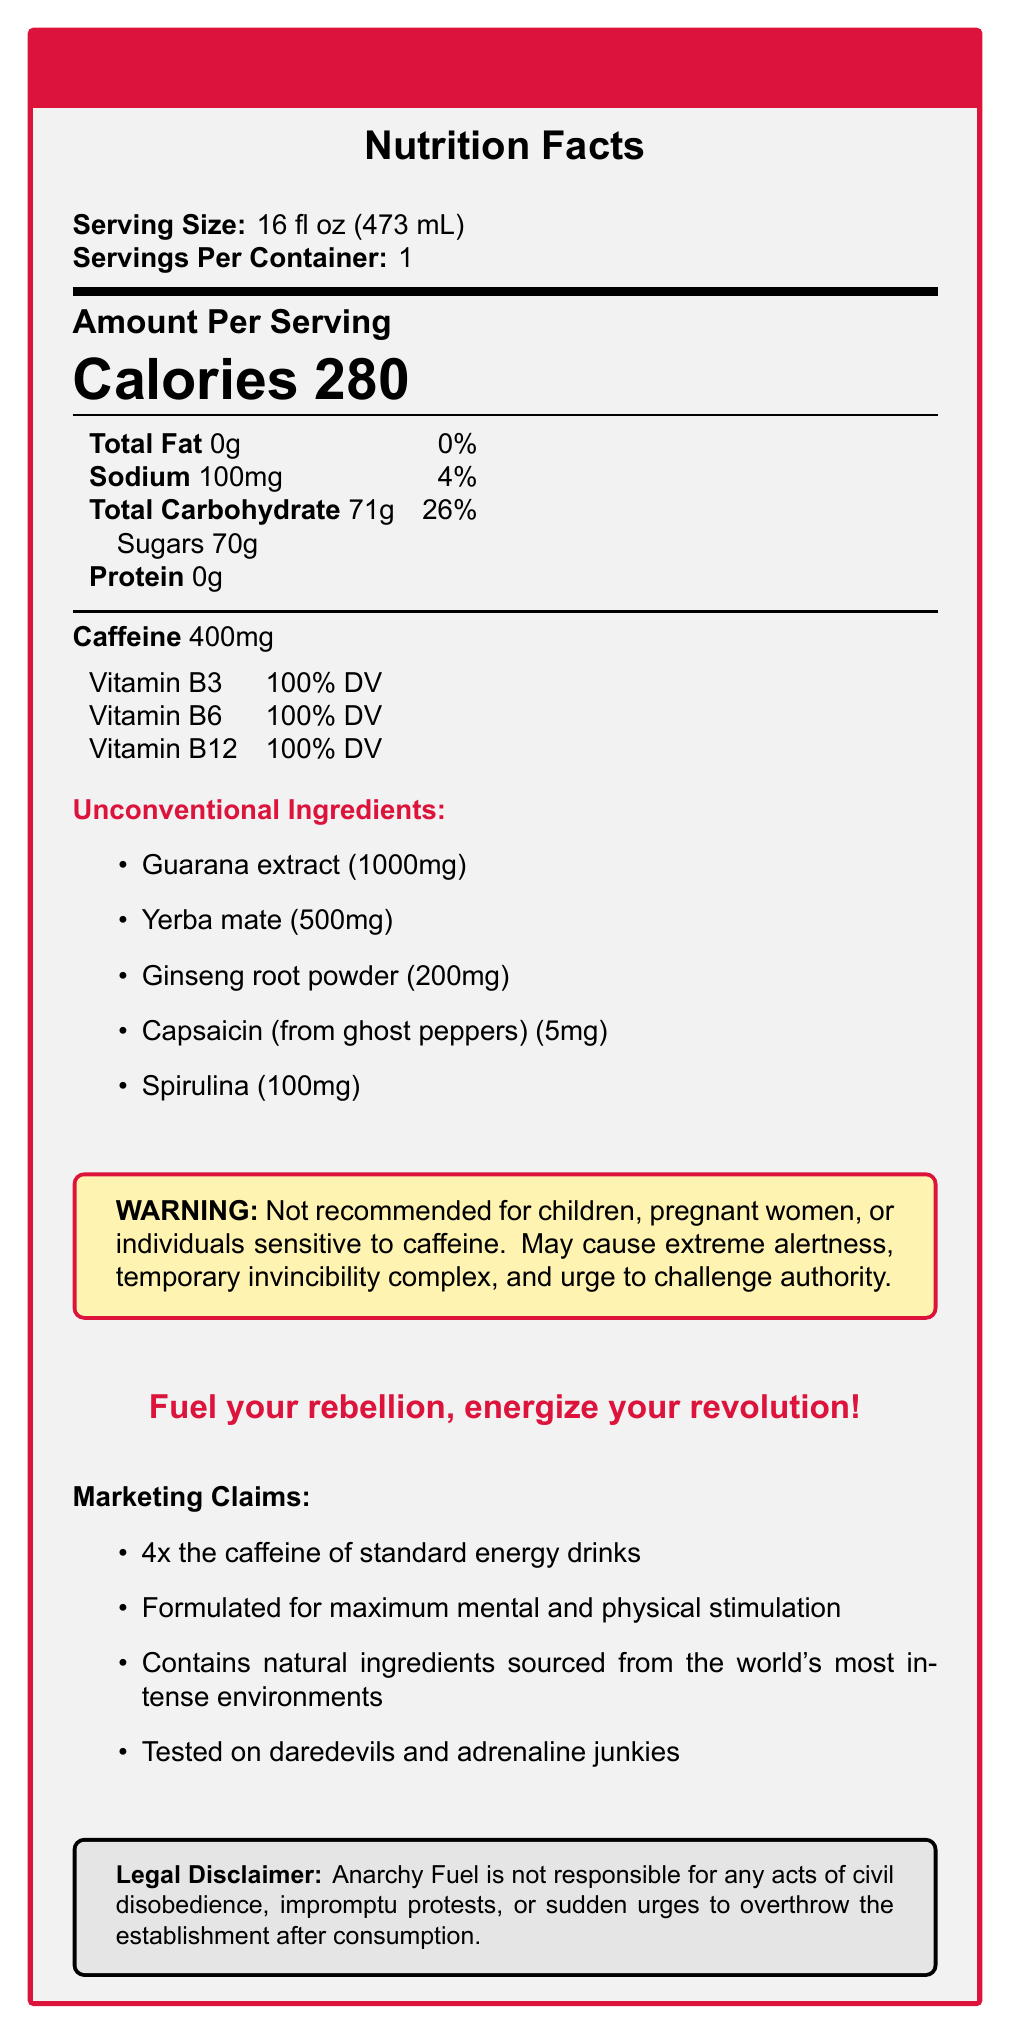what is the serving size of Anarchy Fuel? The serving size is clearly mentioned in the "Serving Size" section of the Nutrition Facts, indicating it is 16 fl oz (473 mL).
Answer: 16 fl oz (473 mL) how many grams of sugars are in one serving of Anarchy Fuel? The sugars content is listed under "Total Carbohydrate" in the Nutrition Facts section.
Answer: 70g how much caffeine does Anarchy Fuel contain? The caffeine content is specifically stated in the document as 400mg per serving.
Answer: 400mg what are the unconventional ingredients in Anarchy Fuel? The list of unconventional ingredients is provided in the "Unconventional Ingredients" section.
Answer: Guarana extract, Yerba mate, Ginseng root powder, Capsaicin (from ghost peppers), Spirulina what percentage of Vitamin B6 is in Anarchy Fuel? The percentage of Vitamin B6 is clearly indicated in the vitamins and minerals section of the Nutrition Facts.
Answer: 100% DV how much sodium is in Anarchy Fuel? The sodium content is listed in the Nutrition Facts.
Answer: 100mg which of the following statements about Anarchy Fuel is true?
A. It contains dairy products.
B. It is low in sugar.
C. It is not recommended for children or pregnant women. Statement A is incorrect as there is no mention of dairy products; statement B is incorrect as the drink contains 70g of sugar; statement C is correct based on the warning provided in the document.
Answer: C what is the slogan of Anarchy Fuel? The slogan is mentioned prominently in the document.
Answer: Fuel your rebellion, energize your revolution! true or false: Anarchy Fuel has more caffeine than standard energy drinks. One of the marketing claims states that Anarchy Fuel has 4x the caffeine of standard energy drinks.
Answer: True summarize the main idea of the document. The document includes detailed nutritional information, ingredients, warnings, and marketing claims, emphasizing the drink's extraordinary stimulant properties and rebellious branding.
Answer: Anarchy Fuel is an energy drink with a high caffeine content (400mg) per 16 fl oz serving, unconventional ingredients, and a rebellious marketing strategy. It is designed for extreme mental and physical stimulation, but it is not advised for those sensitive to caffeine. what are some potential side effects of consuming Anarchy Fuel according to the document? The warning section of the document lists these potential side effects.
Answer: Extreme alertness, temporary invincibility complex, and urge to challenge authority. how many servings are in one container of Anarchy Fuel? The document clearly states that there is 1 serving per container.
Answer: 1 identify any disclaimers associated with Anarchy Fuel. The legal disclaimer is provided at the end of the document.
Answer: Anarchy Fuel is not responsible for any acts of civil disobedience, impromptu protests, or sudden urges to overthrow the establishment after consumption. which of the following is an unconventional ingredient in Anarchy Fuel?
A. Taurine
B. Capsaicin (from ghost peppers)
C. Glucuronolactone The unconventional ingredients section lists capsaicin (from ghost peppers) as one of the ingredients, but not taurine or glucuronolactone.
Answer: B what is the total carbohydrate content in Anarchy Fuel? The total carbohydrate content is listed in the Nutrition Facts as 71g per serving.
Answer: 71g what is the main purpose of the Guarana extract in Anarchy Fuel? The document lists Guarana extract as an ingredient but does not specify its purpose or effects.
Answer: Cannot be determined 